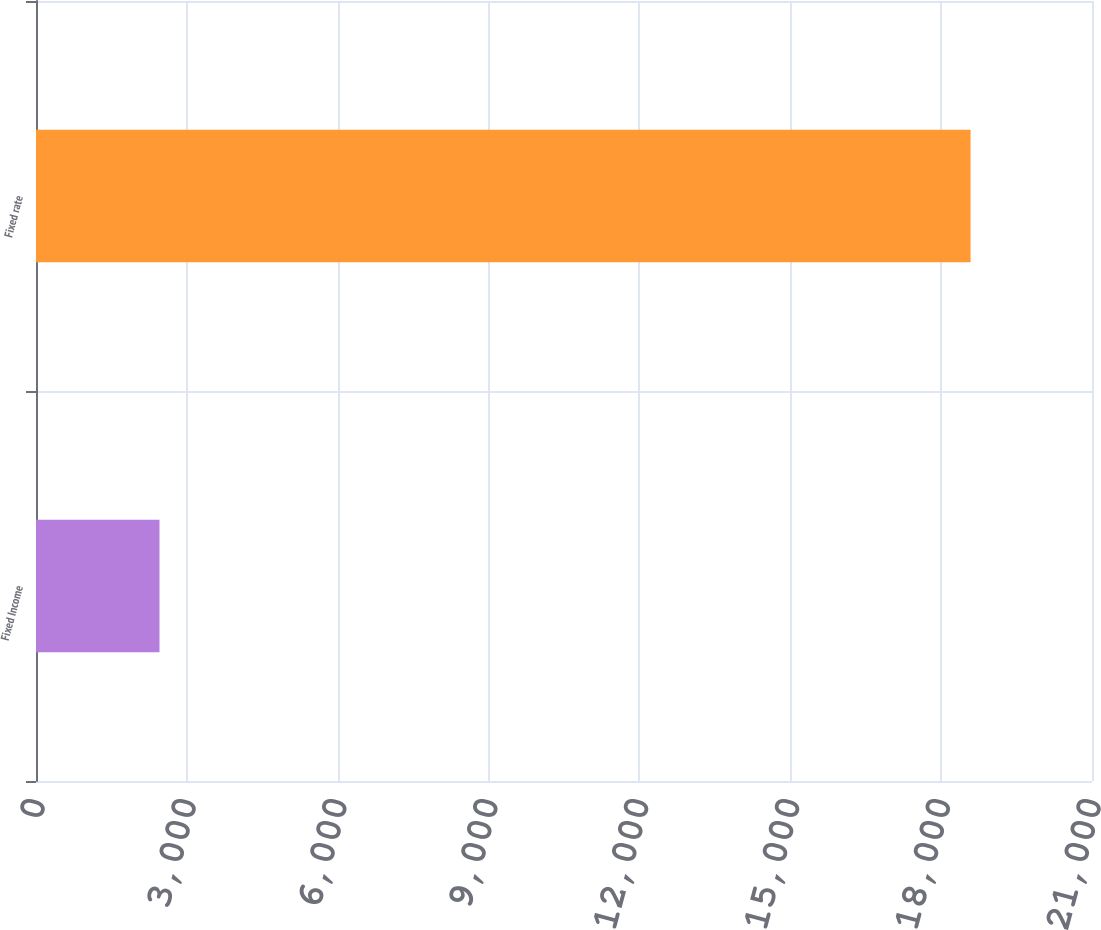Convert chart to OTSL. <chart><loc_0><loc_0><loc_500><loc_500><bar_chart><fcel>Fixed Income<fcel>Fixed rate<nl><fcel>2456<fcel>18585<nl></chart> 